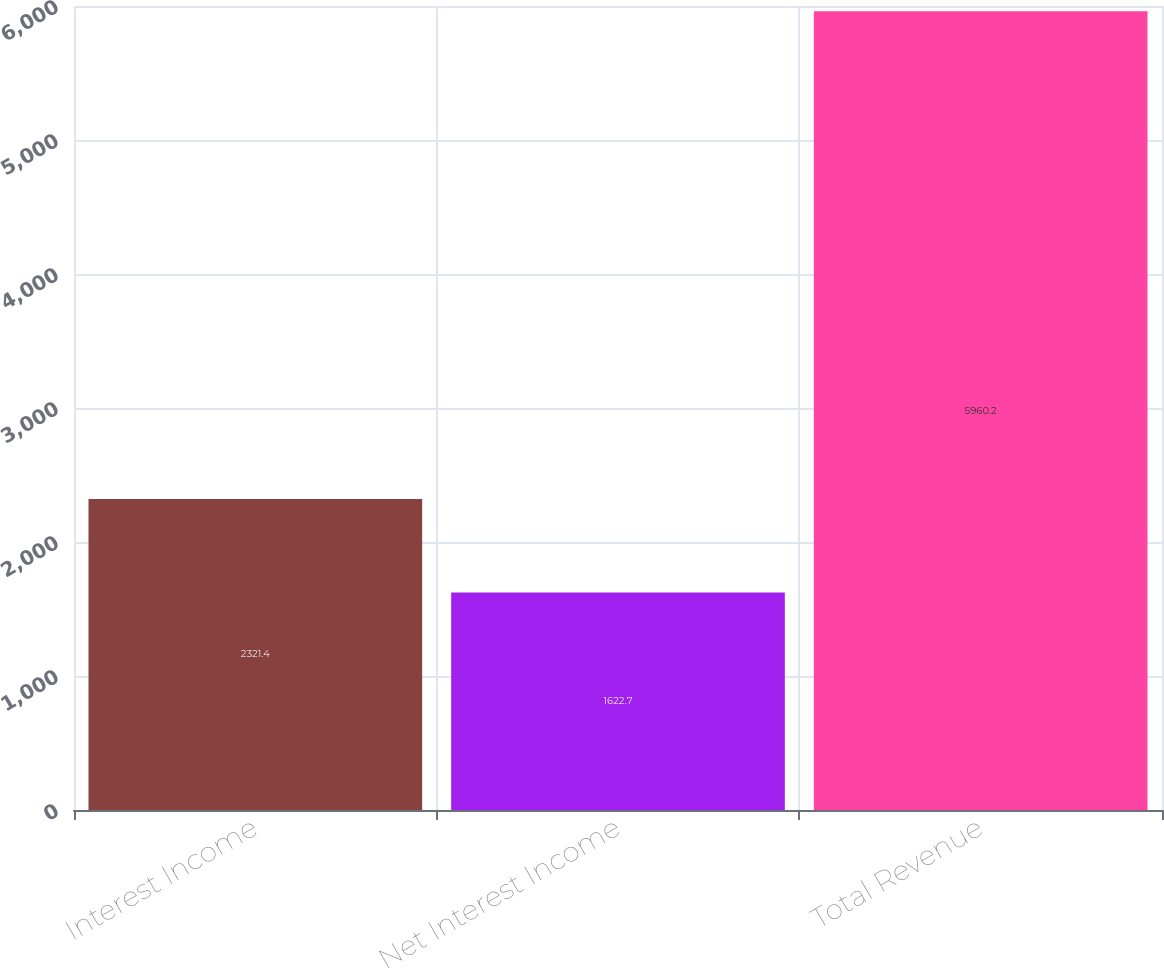<chart> <loc_0><loc_0><loc_500><loc_500><bar_chart><fcel>Interest Income<fcel>Net Interest Income<fcel>Total Revenue<nl><fcel>2321.4<fcel>1622.7<fcel>5960.2<nl></chart> 